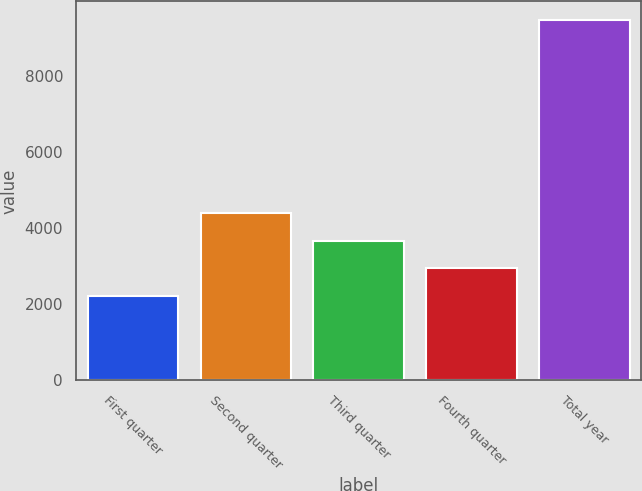Convert chart to OTSL. <chart><loc_0><loc_0><loc_500><loc_500><bar_chart><fcel>First quarter<fcel>Second quarter<fcel>Third quarter<fcel>Fourth quarter<fcel>Total year<nl><fcel>2220.6<fcel>4401.81<fcel>3674.74<fcel>2947.67<fcel>9491.3<nl></chart> 